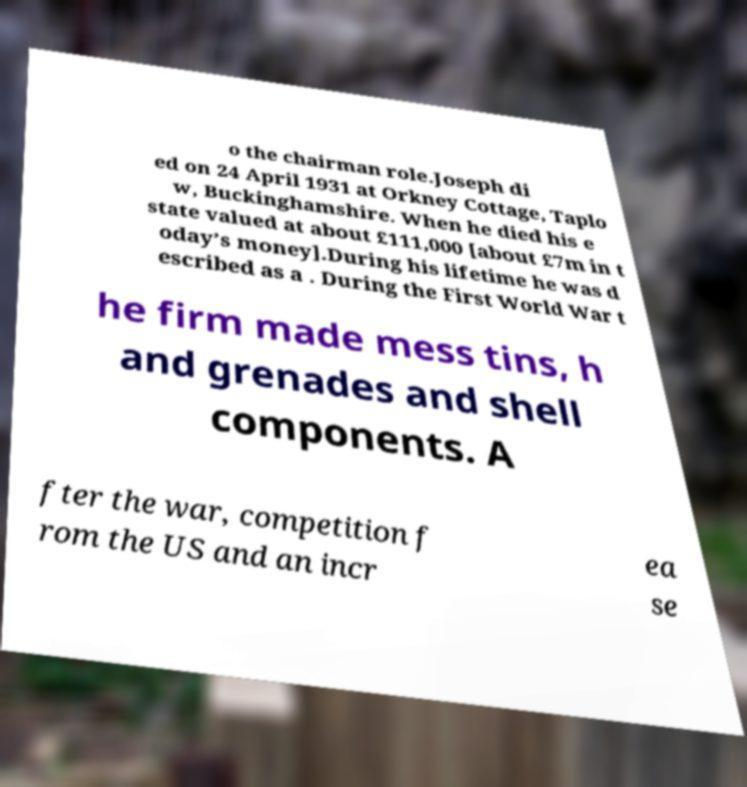For documentation purposes, I need the text within this image transcribed. Could you provide that? o the chairman role.Joseph di ed on 24 April 1931 at Orkney Cottage, Taplo w, Buckinghamshire. When he died his e state valued at about £111,000 [about £7m in t oday’s money].During his lifetime he was d escribed as a . During the First World War t he firm made mess tins, h and grenades and shell components. A fter the war, competition f rom the US and an incr ea se 